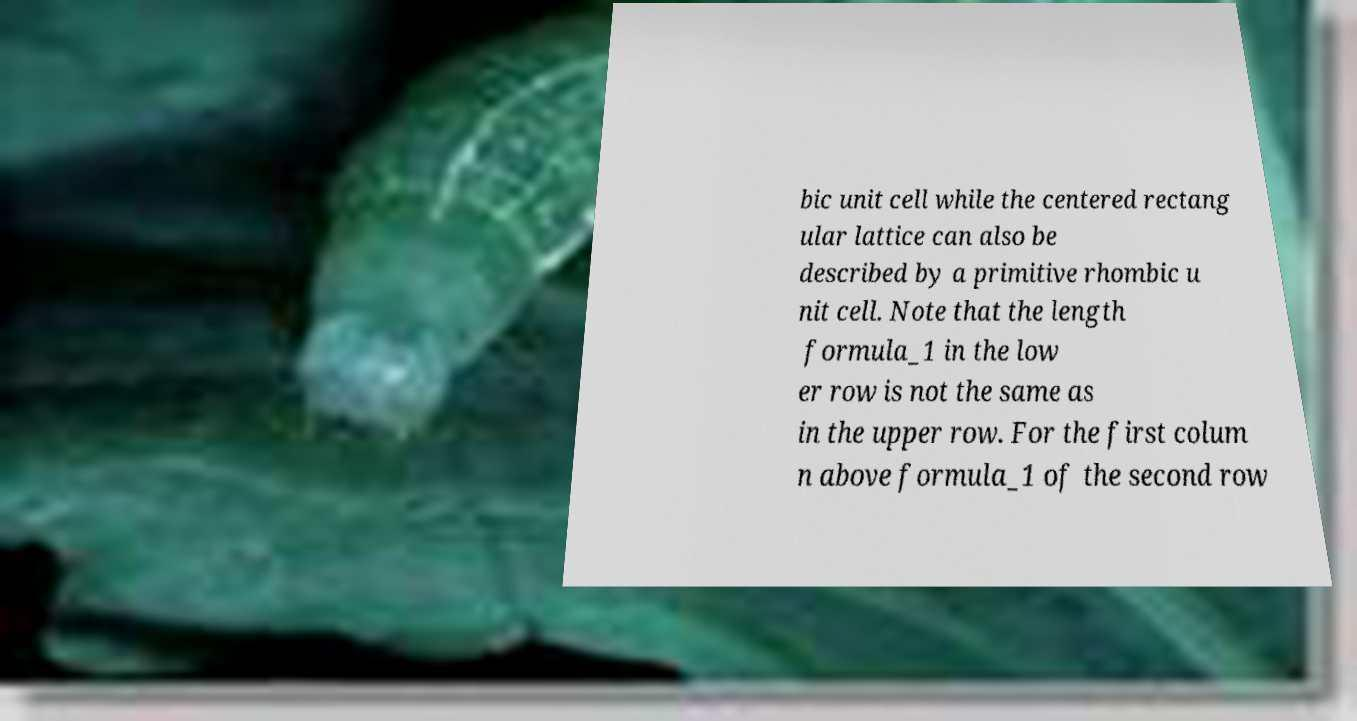Can you read and provide the text displayed in the image?This photo seems to have some interesting text. Can you extract and type it out for me? bic unit cell while the centered rectang ular lattice can also be described by a primitive rhombic u nit cell. Note that the length formula_1 in the low er row is not the same as in the upper row. For the first colum n above formula_1 of the second row 